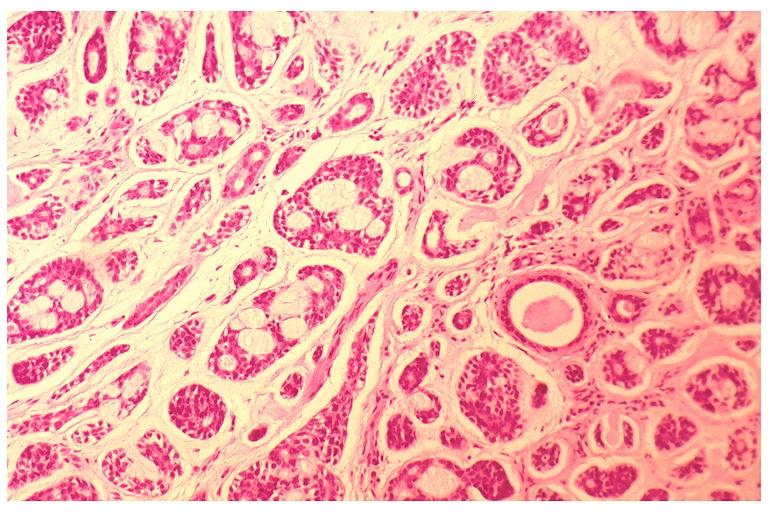s anthracotic pigment present?
Answer the question using a single word or phrase. No 